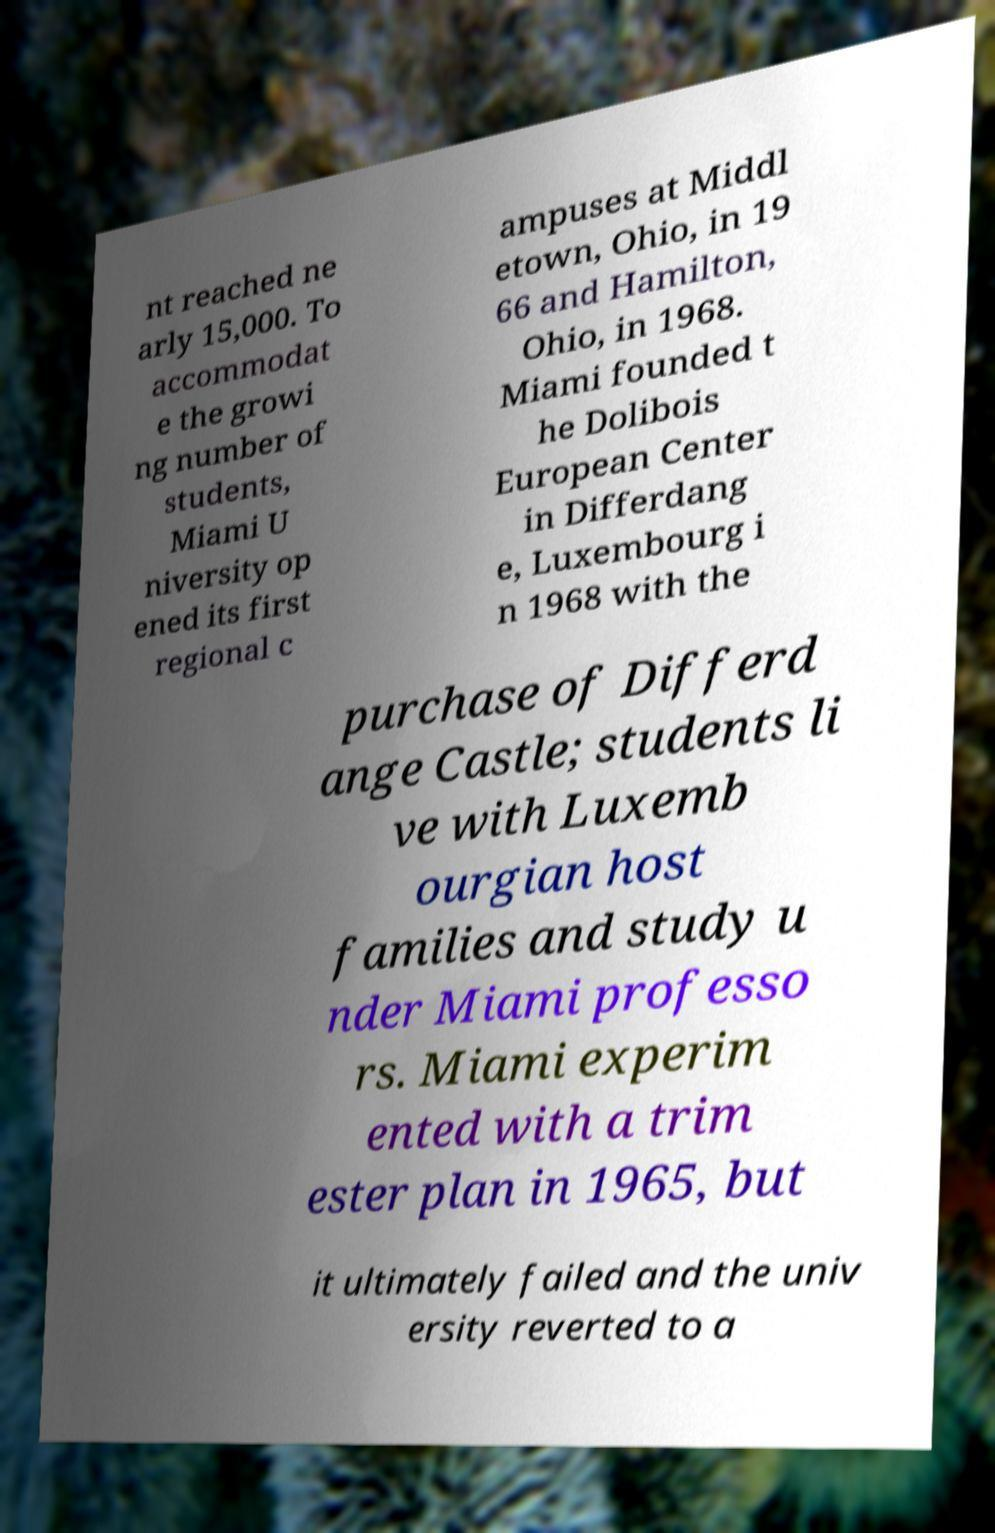Could you assist in decoding the text presented in this image and type it out clearly? nt reached ne arly 15,000. To accommodat e the growi ng number of students, Miami U niversity op ened its first regional c ampuses at Middl etown, Ohio, in 19 66 and Hamilton, Ohio, in 1968. Miami founded t he Dolibois European Center in Differdang e, Luxembourg i n 1968 with the purchase of Differd ange Castle; students li ve with Luxemb ourgian host families and study u nder Miami professo rs. Miami experim ented with a trim ester plan in 1965, but it ultimately failed and the univ ersity reverted to a 